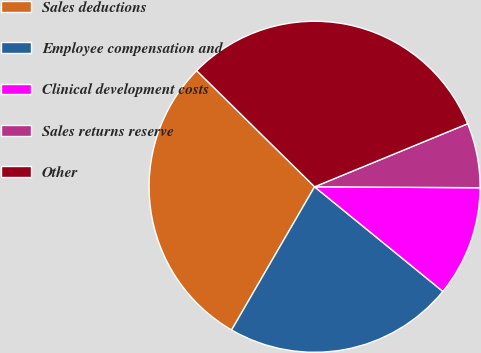<chart> <loc_0><loc_0><loc_500><loc_500><pie_chart><fcel>Sales deductions<fcel>Employee compensation and<fcel>Clinical development costs<fcel>Sales returns reserve<fcel>Other<nl><fcel>29.02%<fcel>22.47%<fcel>10.8%<fcel>6.31%<fcel>31.4%<nl></chart> 